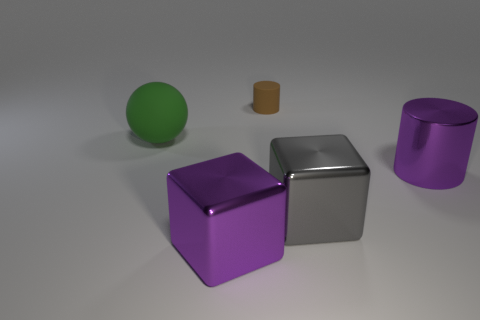Are there any things of the same color as the large metallic cylinder?
Give a very brief answer. Yes. Does the big cylinder have the same color as the metal object that is to the left of the tiny brown matte cylinder?
Provide a short and direct response. Yes. What is the big purple object to the right of the gray cube made of?
Your response must be concise. Metal. What shape is the object that is both behind the purple cylinder and in front of the brown rubber cylinder?
Provide a succinct answer. Sphere. What is the ball made of?
Your response must be concise. Rubber. How many cylinders are either large red matte things or large objects?
Provide a succinct answer. 1. Do the big gray object and the purple cube have the same material?
Offer a terse response. Yes. What material is the object that is both left of the large gray thing and in front of the large green rubber thing?
Ensure brevity in your answer.  Metal. Are there the same number of big green things on the right side of the large green ball and large yellow spheres?
Provide a short and direct response. Yes. What number of things are big spheres on the left side of the brown cylinder or small cylinders?
Ensure brevity in your answer.  2. 